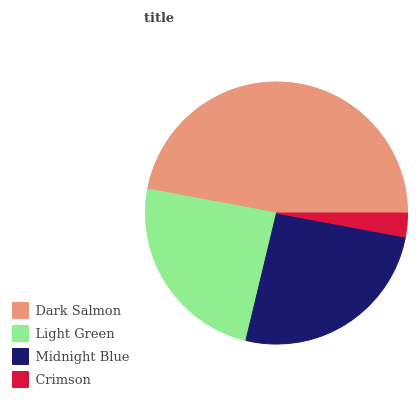Is Crimson the minimum?
Answer yes or no. Yes. Is Dark Salmon the maximum?
Answer yes or no. Yes. Is Light Green the minimum?
Answer yes or no. No. Is Light Green the maximum?
Answer yes or no. No. Is Dark Salmon greater than Light Green?
Answer yes or no. Yes. Is Light Green less than Dark Salmon?
Answer yes or no. Yes. Is Light Green greater than Dark Salmon?
Answer yes or no. No. Is Dark Salmon less than Light Green?
Answer yes or no. No. Is Midnight Blue the high median?
Answer yes or no. Yes. Is Light Green the low median?
Answer yes or no. Yes. Is Crimson the high median?
Answer yes or no. No. Is Crimson the low median?
Answer yes or no. No. 